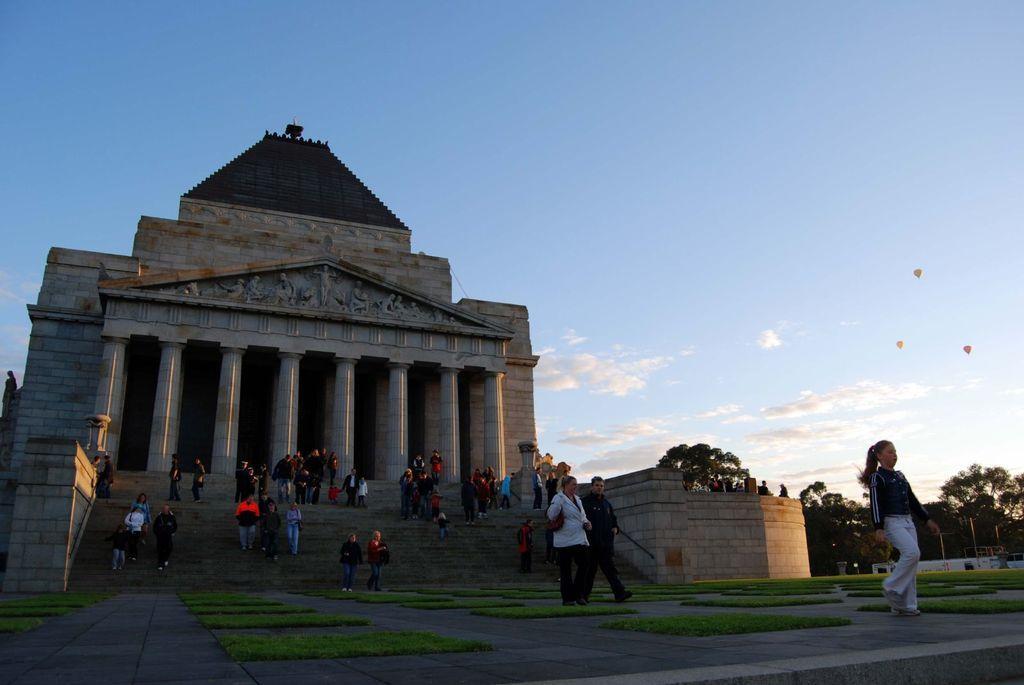Can you describe this image briefly? In this picture we can see a building, pillars, trees and a group of people where some are standing on steps and some are walking on the ground, grass, parachutes and in the background we can see the sky with clouds. 